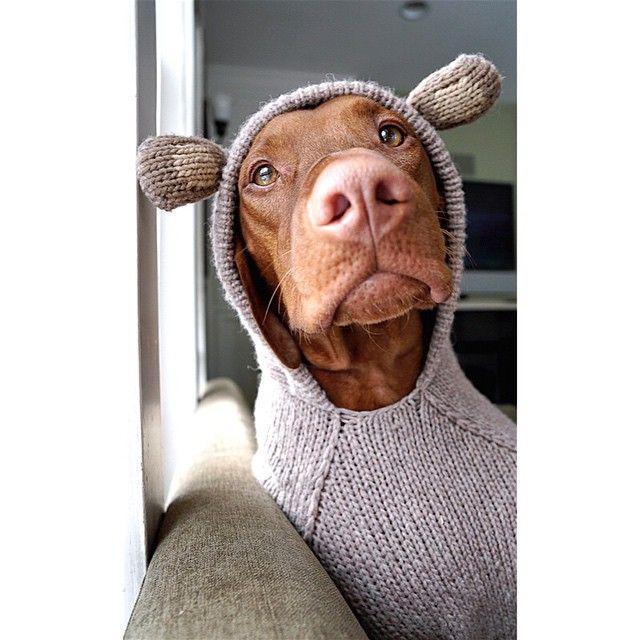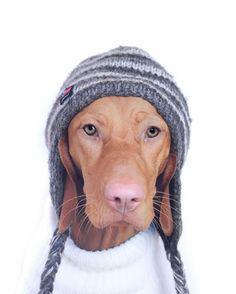The first image is the image on the left, the second image is the image on the right. Analyze the images presented: Is the assertion "A dog is wearing a knit hat." valid? Answer yes or no. Yes. The first image is the image on the left, the second image is the image on the right. Analyze the images presented: Is the assertion "The right image contains a brown dog that is wearing clothing on their head." valid? Answer yes or no. Yes. 